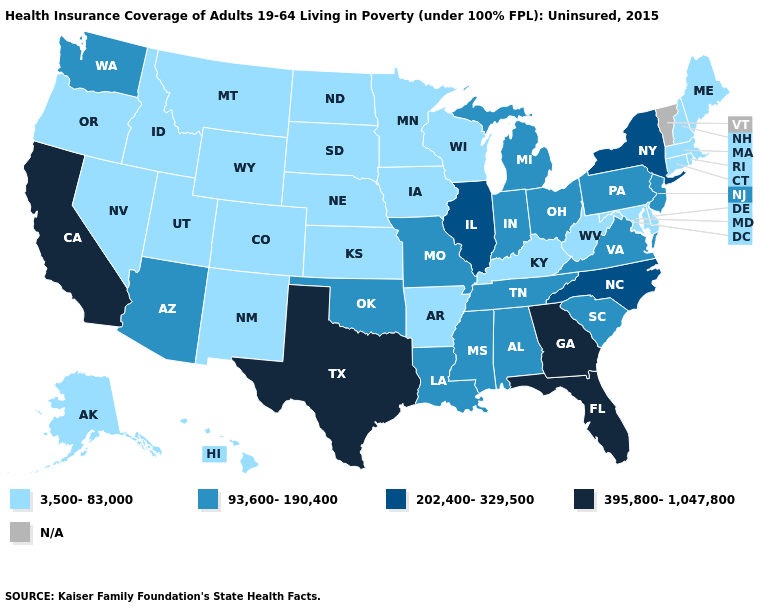Does Kentucky have the lowest value in the South?
Short answer required. Yes. Name the states that have a value in the range N/A?
Write a very short answer. Vermont. Name the states that have a value in the range 93,600-190,400?
Be succinct. Alabama, Arizona, Indiana, Louisiana, Michigan, Mississippi, Missouri, New Jersey, Ohio, Oklahoma, Pennsylvania, South Carolina, Tennessee, Virginia, Washington. What is the highest value in the South ?
Concise answer only. 395,800-1,047,800. Does West Virginia have the highest value in the South?
Keep it brief. No. What is the highest value in states that border Nebraska?
Quick response, please. 93,600-190,400. Among the states that border New Mexico , does Arizona have the lowest value?
Answer briefly. No. Name the states that have a value in the range N/A?
Give a very brief answer. Vermont. Among the states that border Alabama , does Tennessee have the lowest value?
Keep it brief. Yes. Among the states that border Ohio , does Kentucky have the lowest value?
Keep it brief. Yes. Among the states that border Iowa , which have the highest value?
Quick response, please. Illinois. Name the states that have a value in the range N/A?
Short answer required. Vermont. 